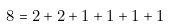<formula> <loc_0><loc_0><loc_500><loc_500>8 = 2 + 2 + 1 + 1 + 1 + 1</formula> 